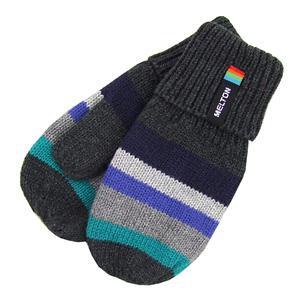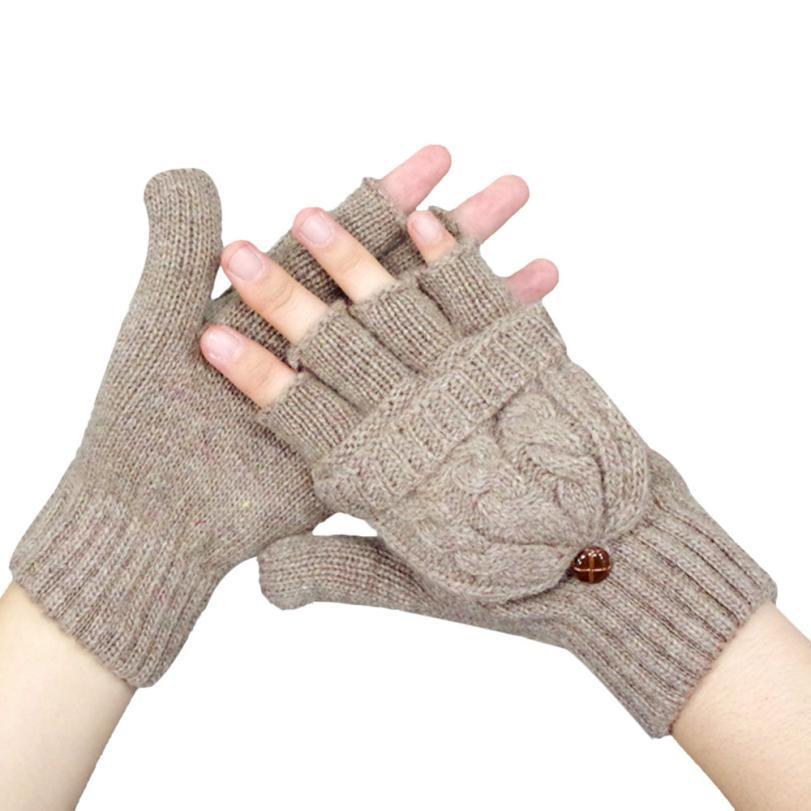The first image is the image on the left, the second image is the image on the right. For the images shown, is this caption "The left image contains one pair of mittens displayed with the cuff end up, and the right image features a pair of half-finger gloves with a mitten flap." true? Answer yes or no. Yes. The first image is the image on the left, the second image is the image on the right. Evaluate the accuracy of this statement regarding the images: "The right image contains two finger less gloves.". Is it true? Answer yes or no. Yes. 